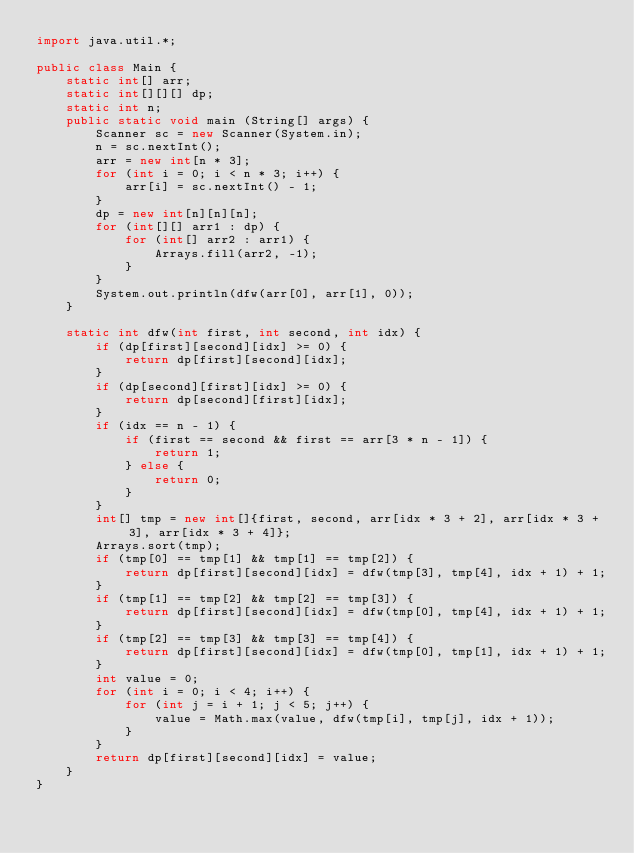Convert code to text. <code><loc_0><loc_0><loc_500><loc_500><_Java_>import java.util.*;

public class Main {
    static int[] arr;
    static int[][][] dp;
    static int n;
	public static void main (String[] args) {
    	Scanner sc = new Scanner(System.in);
    	n = sc.nextInt();
    	arr = new int[n * 3];
    	for (int i = 0; i < n * 3; i++) {
    	    arr[i] = sc.nextInt() - 1;
    	}
    	dp = new int[n][n][n];
    	for (int[][] arr1 : dp) {
    	    for (int[] arr2 : arr1) {
    	        Arrays.fill(arr2, -1);
    	    }
    	}
    	System.out.println(dfw(arr[0], arr[1], 0));
    }
    
    static int dfw(int first, int second, int idx) {
        if (dp[first][second][idx] >= 0) {
            return dp[first][second][idx];
        }
        if (dp[second][first][idx] >= 0) {
            return dp[second][first][idx];
        }
        if (idx == n - 1) {
            if (first == second && first == arr[3 * n - 1]) {
                return 1;
            } else {
                return 0;
            }
        }
        int[] tmp = new int[]{first, second, arr[idx * 3 + 2], arr[idx * 3 + 3], arr[idx * 3 + 4]};
        Arrays.sort(tmp);
        if (tmp[0] == tmp[1] && tmp[1] == tmp[2]) {
            return dp[first][second][idx] = dfw(tmp[3], tmp[4], idx + 1) + 1;
        }
        if (tmp[1] == tmp[2] && tmp[2] == tmp[3]) {
            return dp[first][second][idx] = dfw(tmp[0], tmp[4], idx + 1) + 1;
        }
        if (tmp[2] == tmp[3] && tmp[3] == tmp[4]) {
            return dp[first][second][idx] = dfw(tmp[0], tmp[1], idx + 1) + 1;
        }
        int value = 0;
        for (int i = 0; i < 4; i++) {
            for (int j = i + 1; j < 5; j++) {
                value = Math.max(value, dfw(tmp[i], tmp[j], idx + 1));
            }
        }
        return dp[first][second][idx] = value;
    }
}

</code> 